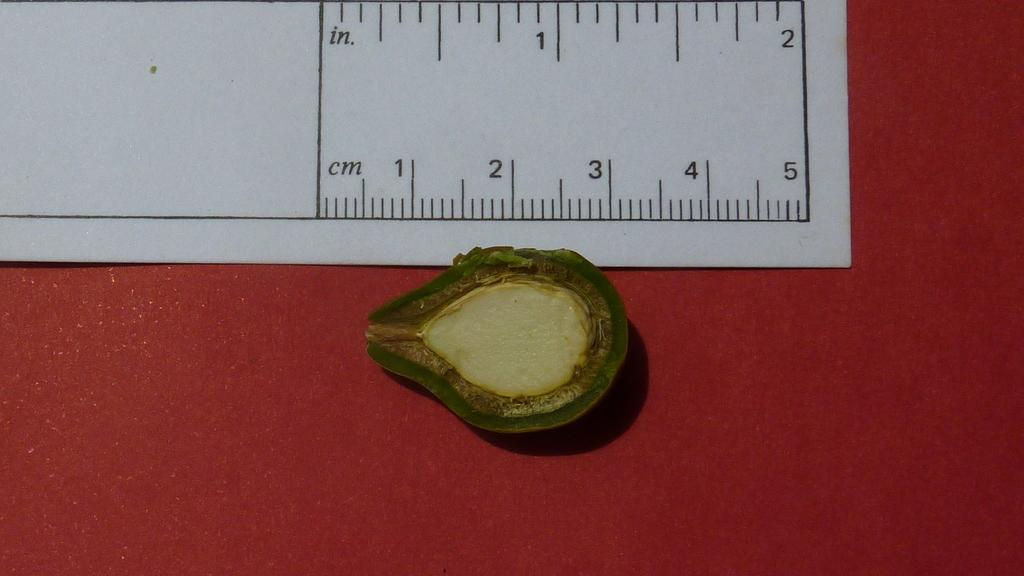What is the main object in the center of the image? There is an avocado in the middle of the image. What else can be seen in the image besides the avocado? There is a paper in the image. What is the weight of the tub in the image? There is no tub present in the image, so it is not possible to determine its weight. 